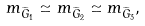<formula> <loc_0><loc_0><loc_500><loc_500>m _ { \widetilde { G } _ { 1 } } \simeq m _ { \widetilde { G } _ { 2 } } \simeq m _ { \widetilde { G } _ { 3 } } ,</formula> 